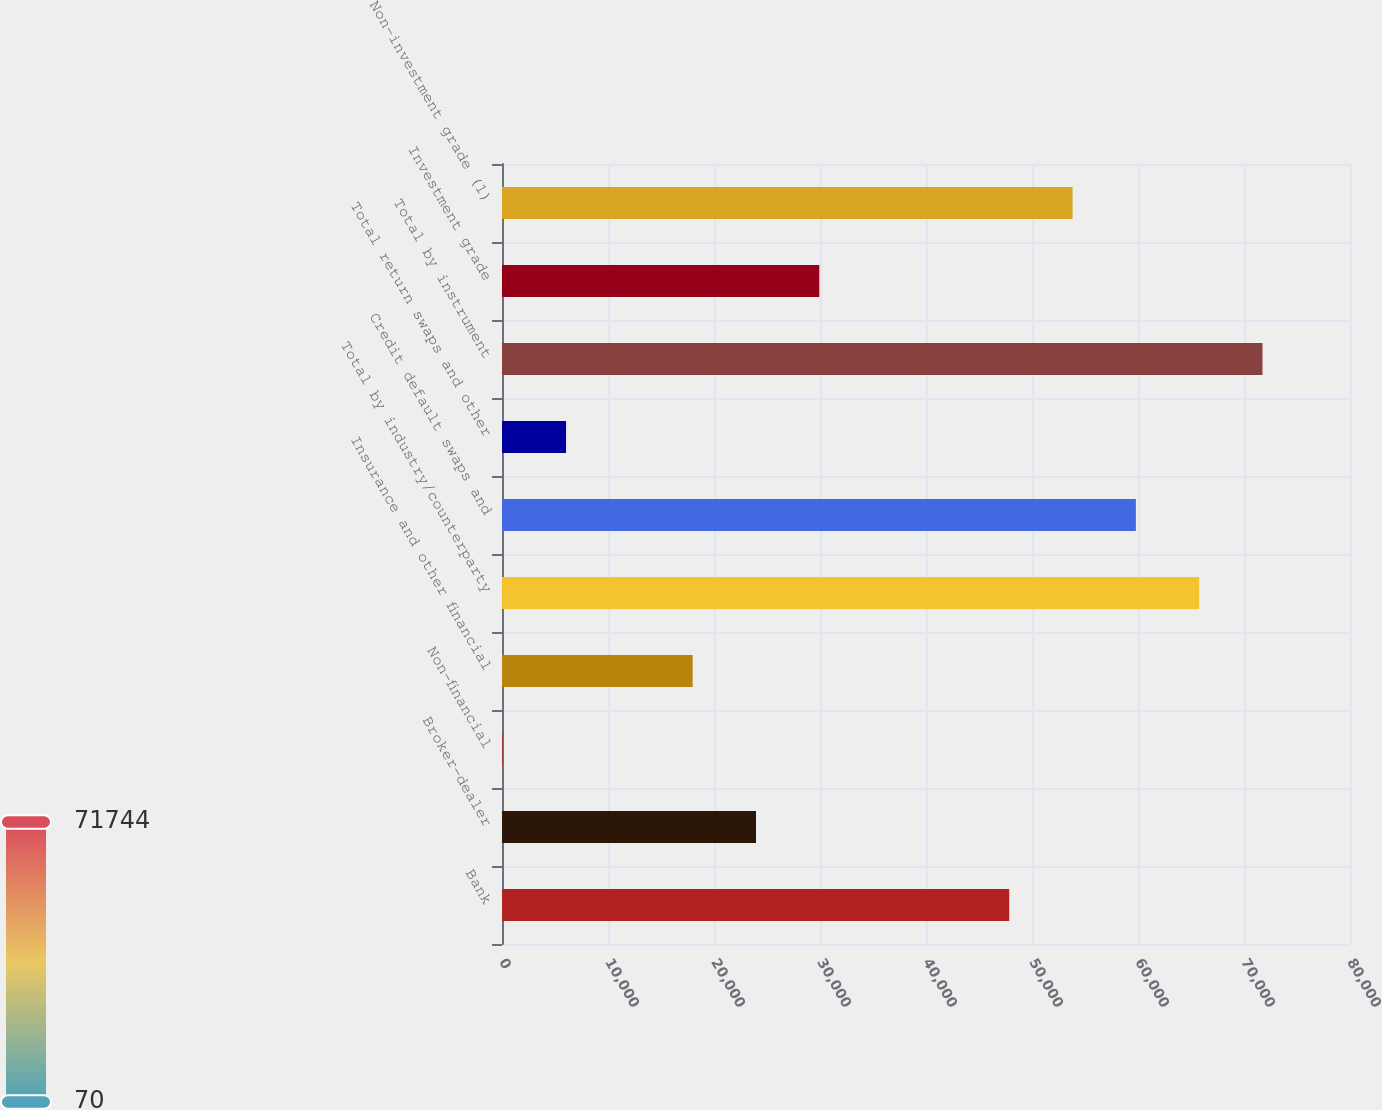<chart> <loc_0><loc_0><loc_500><loc_500><bar_chart><fcel>Bank<fcel>Broker-dealer<fcel>Non-financial<fcel>Insurance and other financial<fcel>Total by industry/counterparty<fcel>Credit default swaps and<fcel>Total return swaps and other<fcel>Total by instrument<fcel>Investment grade<fcel>Non-investment grade (1)<nl><fcel>47852.4<fcel>23961.2<fcel>70<fcel>17988.4<fcel>65770.8<fcel>59798<fcel>6042.8<fcel>71743.6<fcel>29934<fcel>53825.2<nl></chart> 